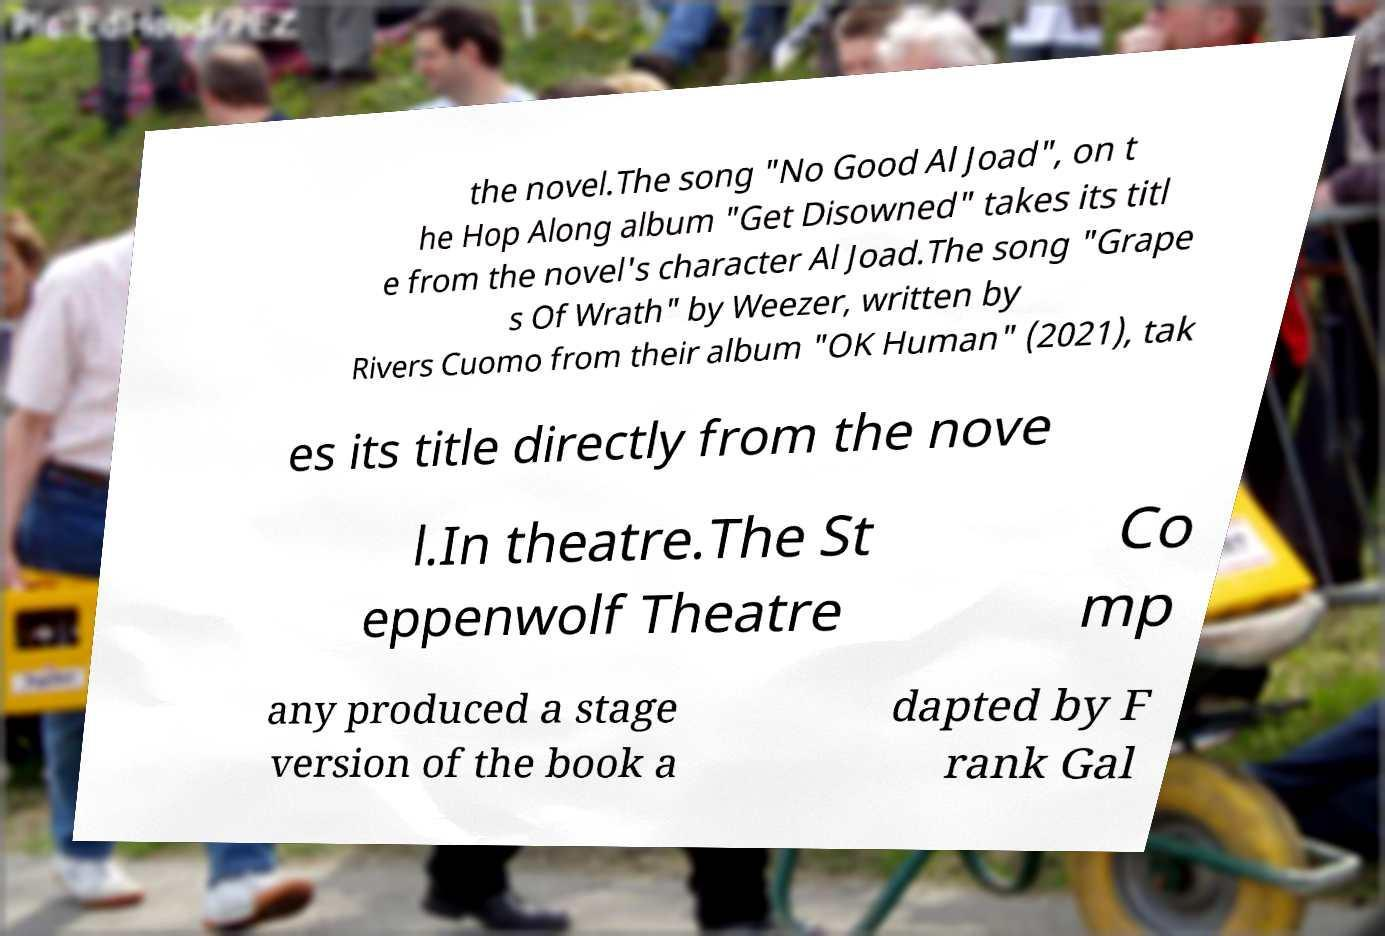For documentation purposes, I need the text within this image transcribed. Could you provide that? the novel.The song "No Good Al Joad", on t he Hop Along album "Get Disowned" takes its titl e from the novel's character Al Joad.The song "Grape s Of Wrath" by Weezer, written by Rivers Cuomo from their album "OK Human" (2021), tak es its title directly from the nove l.In theatre.The St eppenwolf Theatre Co mp any produced a stage version of the book a dapted by F rank Gal 